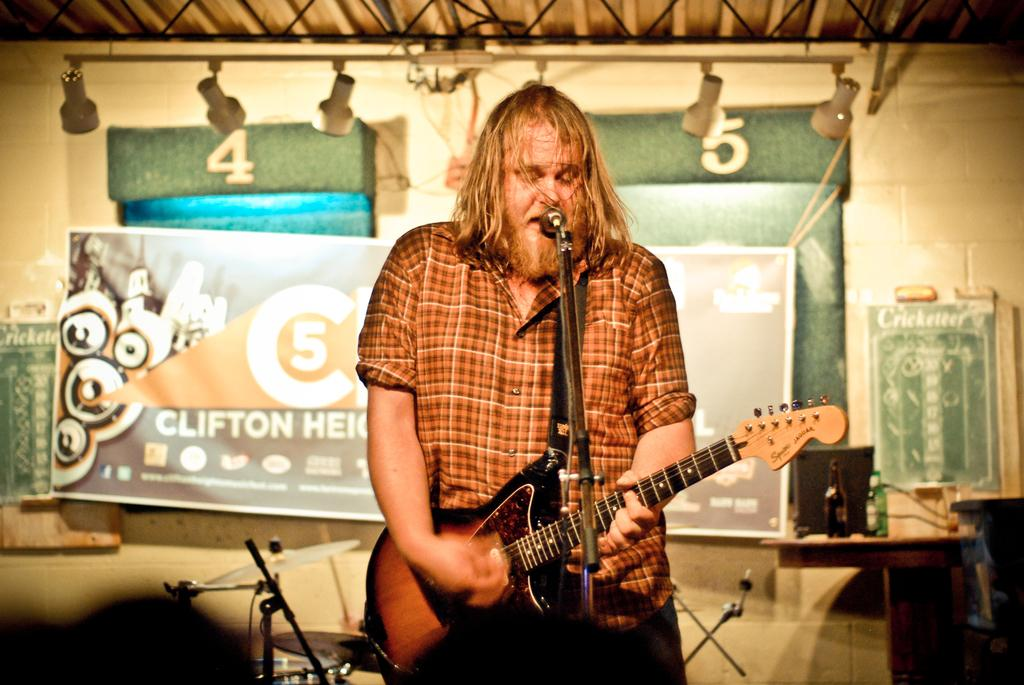Who is the main subject in the image? There is a man in the image. What is the man doing in the image? The man is singing and playing a guitar. What object is in front of the man? There is a microphone in front of the man. What type of addition problem can be solved using the numbers on the man's shirt in the image? There are no numbers visible on the man's shirt in the image, so it is not possible to solve an addition problem based on the image. 